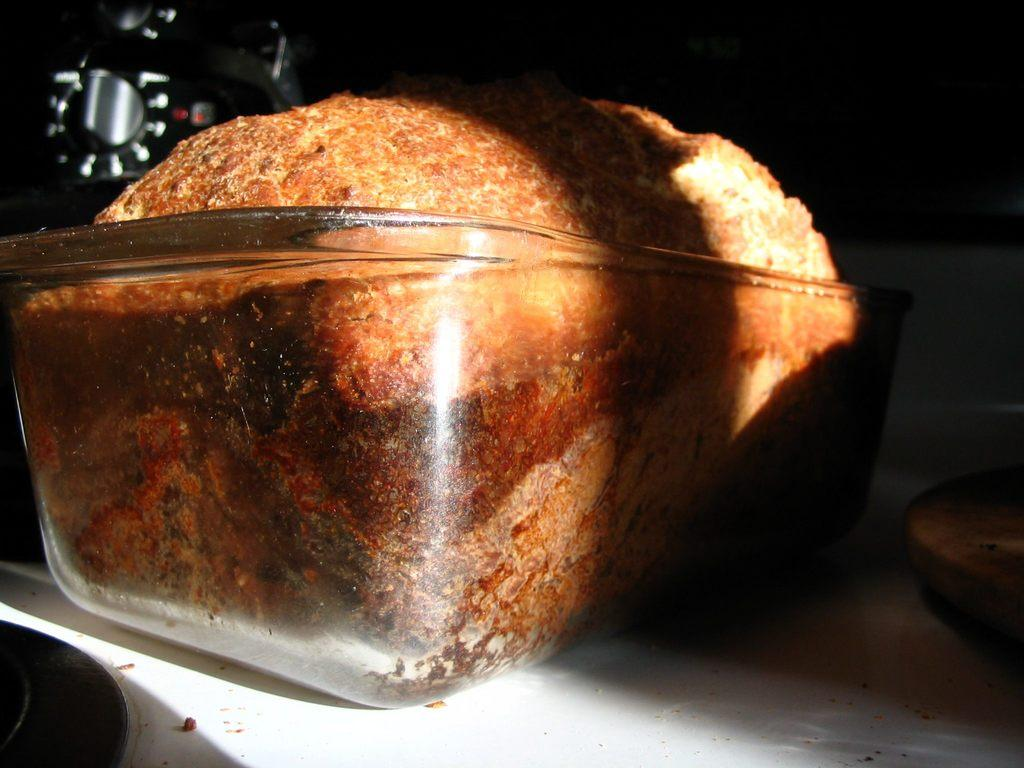What is the main object in the glass bowl in the image? There is a cake in a glass bowl in the image. What is the color of the table the glass bowl is placed on? The table is white in color. What else can be seen on the table besides the glass bowl? There are other objects on the table. How would you describe the background of the image? The background of the image is dark in color. Is there a tent visible in the image in the image? No, there is no tent present in the image. What type of relation do the objects on the table have with each other? The provided facts do not give information about the relationship between the objects on the table. 